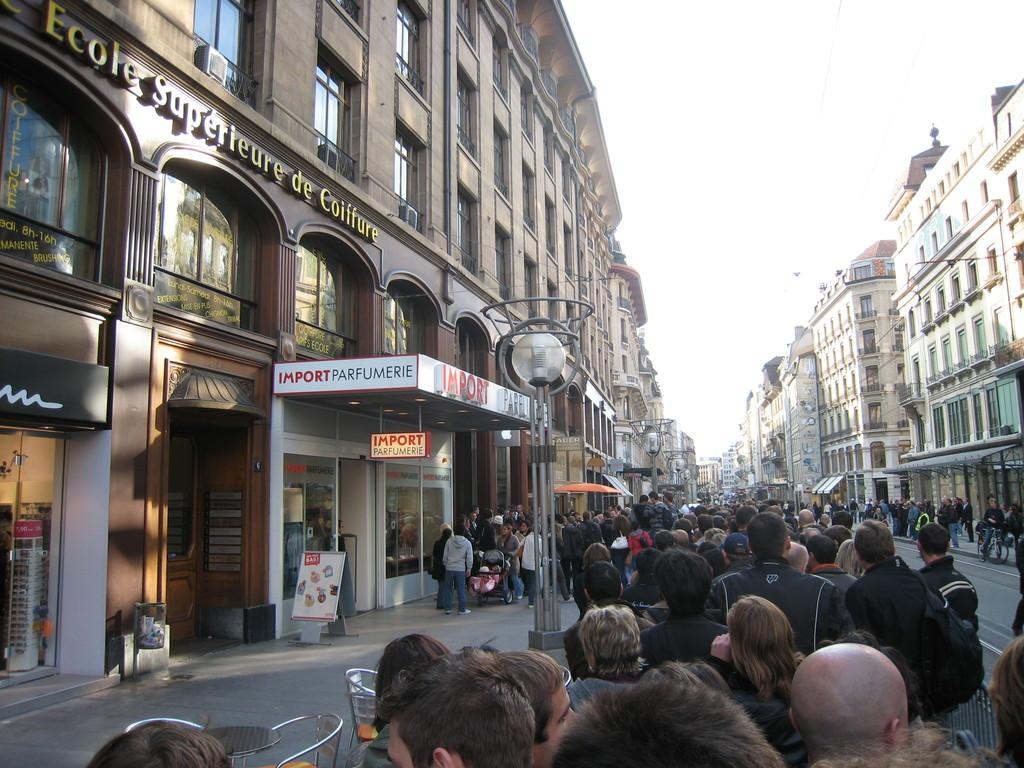Who or what can be seen in the image? There are people in the image. What type of structures are visible in the image? There are buildings in the image. What are the poles used for in the image? The purpose of the poles is not specified, but they are visible in the image. What type of furniture is present in the image? There are chairs in the image. What is written on the boards in the image? The text on the boards is not specified, but there are boards with text in the image. What can be seen on the ground in the image? The ground is visible in the image. What is visible in the sky in the image? The sky is visible in the image. What type of surface is present on the table in the image? There is a table in the image, but the surface material is not specified. What is the glass used for in the image? The purpose of the glass is not specified, but it is visible in the image. Where is the car parked in the image? There is no car present in the image. What type of home is shown in the image? There is no home depicted in the image. How many docks are visible in the image? There are no docks present in the image. 